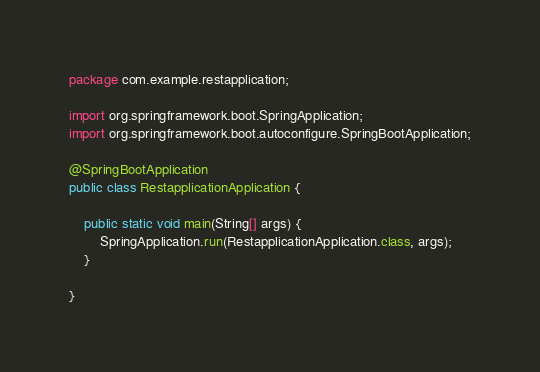<code> <loc_0><loc_0><loc_500><loc_500><_Java_>package com.example.restapplication;

import org.springframework.boot.SpringApplication;
import org.springframework.boot.autoconfigure.SpringBootApplication;

@SpringBootApplication
public class RestapplicationApplication {

	public static void main(String[] args) {
		SpringApplication.run(RestapplicationApplication.class, args);
	}

}
</code> 